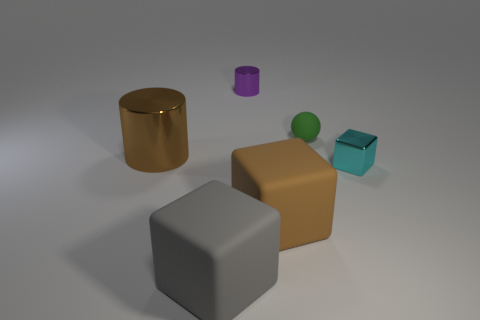How many things are either big shiny things or small green rubber spheres that are behind the brown rubber object?
Make the answer very short. 2. Are there any big gray objects that are left of the rubber block that is behind the gray rubber cube?
Provide a short and direct response. Yes. There is a tiny metallic object that is in front of the green ball that is behind the tiny metallic object in front of the big cylinder; what shape is it?
Your answer should be compact. Cube. What is the color of the large thing that is both left of the large brown rubber block and in front of the tiny cube?
Ensure brevity in your answer.  Gray. There is a metal thing that is on the left side of the gray rubber cube; what is its shape?
Your answer should be very brief. Cylinder. What shape is the large gray thing that is made of the same material as the green ball?
Make the answer very short. Cube. What number of metallic objects are tiny green blocks or tiny balls?
Your answer should be compact. 0. There is a small matte thing that is behind the large thing left of the big gray cube; what number of small objects are on the left side of it?
Provide a succinct answer. 1. There is a cylinder that is on the left side of the tiny shiny cylinder; does it have the same size as the matte object that is behind the tiny shiny block?
Make the answer very short. No. What material is the other large object that is the same shape as the purple metal thing?
Make the answer very short. Metal. 